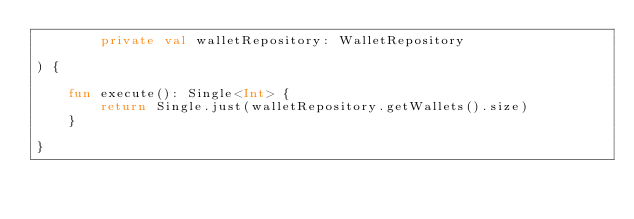Convert code to text. <code><loc_0><loc_0><loc_500><loc_500><_Kotlin_>        private val walletRepository: WalletRepository

) {

    fun execute(): Single<Int> {
        return Single.just(walletRepository.getWallets().size)
    }

}
</code> 